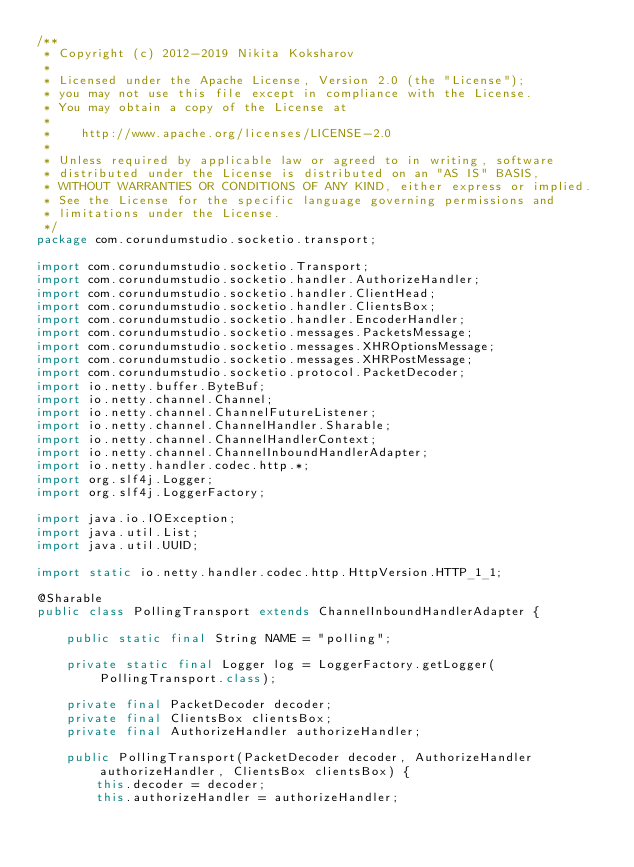<code> <loc_0><loc_0><loc_500><loc_500><_Java_>/**
 * Copyright (c) 2012-2019 Nikita Koksharov
 *
 * Licensed under the Apache License, Version 2.0 (the "License");
 * you may not use this file except in compliance with the License.
 * You may obtain a copy of the License at
 *
 *    http://www.apache.org/licenses/LICENSE-2.0
 *
 * Unless required by applicable law or agreed to in writing, software
 * distributed under the License is distributed on an "AS IS" BASIS,
 * WITHOUT WARRANTIES OR CONDITIONS OF ANY KIND, either express or implied.
 * See the License for the specific language governing permissions and
 * limitations under the License.
 */
package com.corundumstudio.socketio.transport;

import com.corundumstudio.socketio.Transport;
import com.corundumstudio.socketio.handler.AuthorizeHandler;
import com.corundumstudio.socketio.handler.ClientHead;
import com.corundumstudio.socketio.handler.ClientsBox;
import com.corundumstudio.socketio.handler.EncoderHandler;
import com.corundumstudio.socketio.messages.PacketsMessage;
import com.corundumstudio.socketio.messages.XHROptionsMessage;
import com.corundumstudio.socketio.messages.XHRPostMessage;
import com.corundumstudio.socketio.protocol.PacketDecoder;
import io.netty.buffer.ByteBuf;
import io.netty.channel.Channel;
import io.netty.channel.ChannelFutureListener;
import io.netty.channel.ChannelHandler.Sharable;
import io.netty.channel.ChannelHandlerContext;
import io.netty.channel.ChannelInboundHandlerAdapter;
import io.netty.handler.codec.http.*;
import org.slf4j.Logger;
import org.slf4j.LoggerFactory;

import java.io.IOException;
import java.util.List;
import java.util.UUID;

import static io.netty.handler.codec.http.HttpVersion.HTTP_1_1;

@Sharable
public class PollingTransport extends ChannelInboundHandlerAdapter {

    public static final String NAME = "polling";

    private static final Logger log = LoggerFactory.getLogger(PollingTransport.class);

    private final PacketDecoder decoder;
    private final ClientsBox clientsBox;
    private final AuthorizeHandler authorizeHandler;

    public PollingTransport(PacketDecoder decoder, AuthorizeHandler authorizeHandler, ClientsBox clientsBox) {
        this.decoder = decoder;
        this.authorizeHandler = authorizeHandler;</code> 